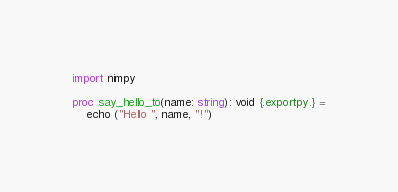<code> <loc_0><loc_0><loc_500><loc_500><_Nim_>import nimpy

proc say_hello_to(name: string): void {.exportpy.} =
    echo ("Hello ", name, "!")
</code> 